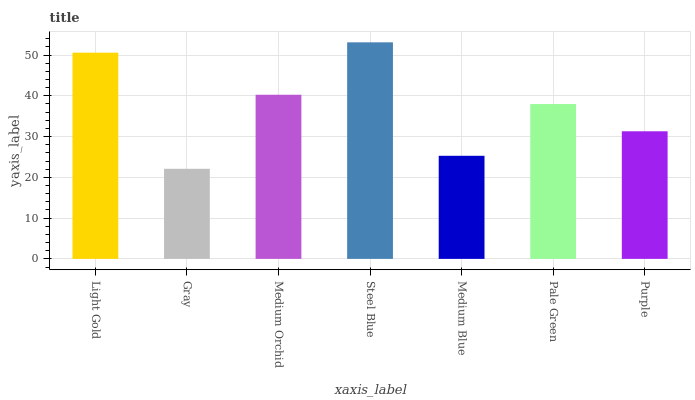Is Medium Orchid the minimum?
Answer yes or no. No. Is Medium Orchid the maximum?
Answer yes or no. No. Is Medium Orchid greater than Gray?
Answer yes or no. Yes. Is Gray less than Medium Orchid?
Answer yes or no. Yes. Is Gray greater than Medium Orchid?
Answer yes or no. No. Is Medium Orchid less than Gray?
Answer yes or no. No. Is Pale Green the high median?
Answer yes or no. Yes. Is Pale Green the low median?
Answer yes or no. Yes. Is Steel Blue the high median?
Answer yes or no. No. Is Medium Blue the low median?
Answer yes or no. No. 